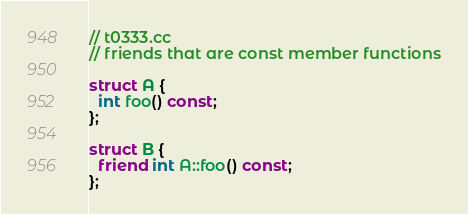<code> <loc_0><loc_0><loc_500><loc_500><_C++_>// t0333.cc
// friends that are const member functions

struct A {
  int foo() const;
};

struct B {
  friend int A::foo() const;
};
</code> 